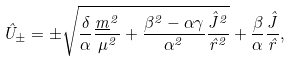Convert formula to latex. <formula><loc_0><loc_0><loc_500><loc_500>\hat { U } _ { \pm } = \pm \sqrt { \frac { \delta } { \alpha } \frac { \underline { m } ^ { 2 } } { \mu ^ { 2 } } + \frac { \beta ^ { 2 } - \alpha \gamma } { \alpha ^ { 2 } } \frac { \hat { J } ^ { 2 } } { \hat { r } ^ { 2 } } } + \frac { \beta } { \alpha } \frac { \hat { J } } { \hat { r } } ,</formula> 